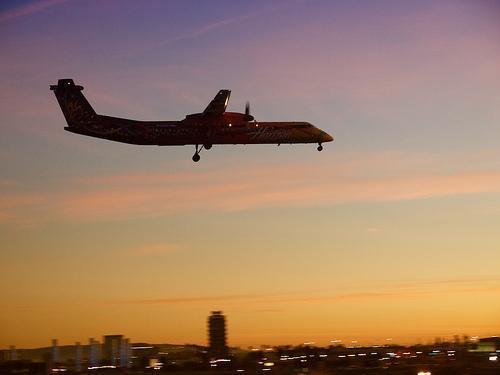How many planes are there?
Give a very brief answer. 1. 